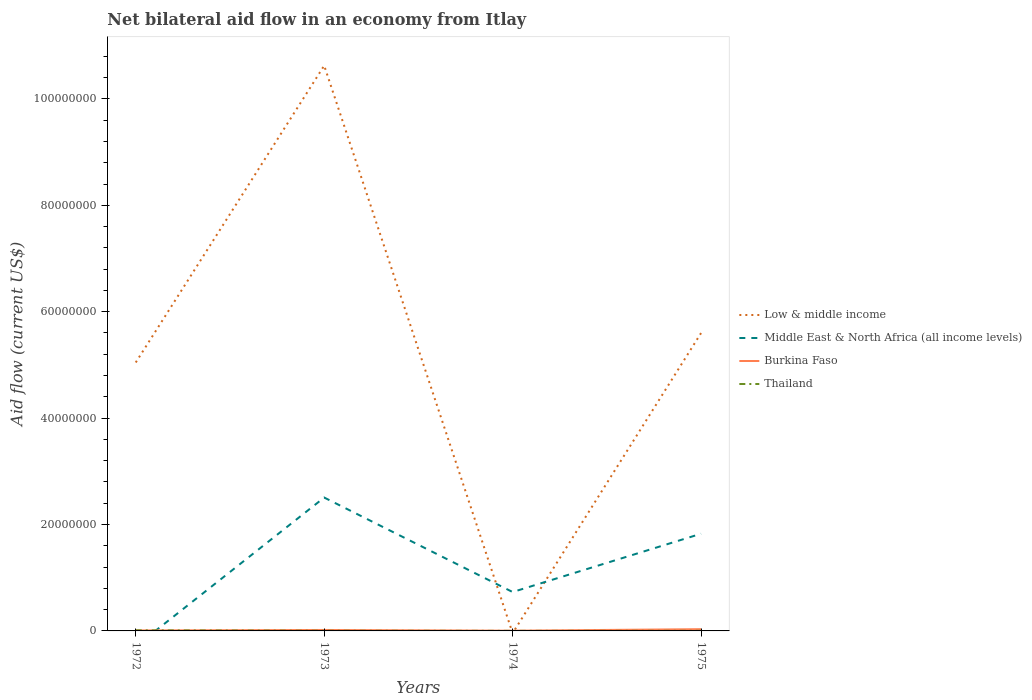How many different coloured lines are there?
Offer a very short reply. 4. Does the line corresponding to Middle East & North Africa (all income levels) intersect with the line corresponding to Burkina Faso?
Keep it short and to the point. Yes. What is the total net bilateral aid flow in Low & middle income in the graph?
Your answer should be compact. -5.53e+06. What is the difference between the highest and the second highest net bilateral aid flow in Middle East & North Africa (all income levels)?
Offer a very short reply. 2.51e+07. What is the difference between the highest and the lowest net bilateral aid flow in Burkina Faso?
Keep it short and to the point. 2. Is the net bilateral aid flow in Burkina Faso strictly greater than the net bilateral aid flow in Middle East & North Africa (all income levels) over the years?
Keep it short and to the point. No. How many lines are there?
Offer a very short reply. 4. Does the graph contain any zero values?
Offer a terse response. Yes. Does the graph contain grids?
Give a very brief answer. No. Where does the legend appear in the graph?
Give a very brief answer. Center right. How are the legend labels stacked?
Provide a succinct answer. Vertical. What is the title of the graph?
Make the answer very short. Net bilateral aid flow in an economy from Itlay. What is the label or title of the X-axis?
Provide a short and direct response. Years. What is the label or title of the Y-axis?
Ensure brevity in your answer.  Aid flow (current US$). What is the Aid flow (current US$) in Low & middle income in 1972?
Ensure brevity in your answer.  5.05e+07. What is the Aid flow (current US$) in Middle East & North Africa (all income levels) in 1972?
Give a very brief answer. 0. What is the Aid flow (current US$) in Burkina Faso in 1972?
Keep it short and to the point. 9.00e+04. What is the Aid flow (current US$) of Thailand in 1972?
Your answer should be very brief. 1.10e+05. What is the Aid flow (current US$) of Low & middle income in 1973?
Offer a terse response. 1.06e+08. What is the Aid flow (current US$) in Middle East & North Africa (all income levels) in 1973?
Provide a succinct answer. 2.51e+07. What is the Aid flow (current US$) of Low & middle income in 1974?
Provide a succinct answer. 0. What is the Aid flow (current US$) in Middle East & North Africa (all income levels) in 1974?
Give a very brief answer. 7.31e+06. What is the Aid flow (current US$) of Burkina Faso in 1974?
Your response must be concise. 4.00e+04. What is the Aid flow (current US$) of Thailand in 1974?
Provide a succinct answer. 10000. What is the Aid flow (current US$) in Low & middle income in 1975?
Offer a terse response. 5.60e+07. What is the Aid flow (current US$) of Middle East & North Africa (all income levels) in 1975?
Offer a terse response. 1.83e+07. What is the Aid flow (current US$) in Thailand in 1975?
Make the answer very short. 2.00e+04. Across all years, what is the maximum Aid flow (current US$) of Low & middle income?
Ensure brevity in your answer.  1.06e+08. Across all years, what is the maximum Aid flow (current US$) of Middle East & North Africa (all income levels)?
Ensure brevity in your answer.  2.51e+07. Across all years, what is the maximum Aid flow (current US$) in Burkina Faso?
Offer a very short reply. 3.30e+05. Across all years, what is the maximum Aid flow (current US$) in Thailand?
Provide a short and direct response. 1.10e+05. Across all years, what is the minimum Aid flow (current US$) in Low & middle income?
Offer a very short reply. 0. Across all years, what is the minimum Aid flow (current US$) in Thailand?
Provide a short and direct response. 10000. What is the total Aid flow (current US$) in Low & middle income in the graph?
Your answer should be very brief. 2.13e+08. What is the total Aid flow (current US$) in Middle East & North Africa (all income levels) in the graph?
Offer a very short reply. 5.06e+07. What is the total Aid flow (current US$) in Burkina Faso in the graph?
Keep it short and to the point. 6.40e+05. What is the total Aid flow (current US$) in Thailand in the graph?
Your answer should be very brief. 1.70e+05. What is the difference between the Aid flow (current US$) in Low & middle income in 1972 and that in 1973?
Provide a succinct answer. -5.58e+07. What is the difference between the Aid flow (current US$) in Burkina Faso in 1972 and that in 1974?
Offer a terse response. 5.00e+04. What is the difference between the Aid flow (current US$) of Thailand in 1972 and that in 1974?
Keep it short and to the point. 1.00e+05. What is the difference between the Aid flow (current US$) of Low & middle income in 1972 and that in 1975?
Your response must be concise. -5.53e+06. What is the difference between the Aid flow (current US$) of Burkina Faso in 1972 and that in 1975?
Keep it short and to the point. -2.40e+05. What is the difference between the Aid flow (current US$) of Middle East & North Africa (all income levels) in 1973 and that in 1974?
Provide a succinct answer. 1.78e+07. What is the difference between the Aid flow (current US$) of Low & middle income in 1973 and that in 1975?
Provide a succinct answer. 5.03e+07. What is the difference between the Aid flow (current US$) of Middle East & North Africa (all income levels) in 1973 and that in 1975?
Ensure brevity in your answer.  6.80e+06. What is the difference between the Aid flow (current US$) of Burkina Faso in 1973 and that in 1975?
Your answer should be very brief. -1.50e+05. What is the difference between the Aid flow (current US$) of Middle East & North Africa (all income levels) in 1974 and that in 1975?
Your response must be concise. -1.10e+07. What is the difference between the Aid flow (current US$) of Thailand in 1974 and that in 1975?
Ensure brevity in your answer.  -10000. What is the difference between the Aid flow (current US$) in Low & middle income in 1972 and the Aid flow (current US$) in Middle East & North Africa (all income levels) in 1973?
Provide a succinct answer. 2.54e+07. What is the difference between the Aid flow (current US$) in Low & middle income in 1972 and the Aid flow (current US$) in Burkina Faso in 1973?
Give a very brief answer. 5.03e+07. What is the difference between the Aid flow (current US$) of Low & middle income in 1972 and the Aid flow (current US$) of Thailand in 1973?
Offer a terse response. 5.04e+07. What is the difference between the Aid flow (current US$) in Burkina Faso in 1972 and the Aid flow (current US$) in Thailand in 1973?
Provide a succinct answer. 6.00e+04. What is the difference between the Aid flow (current US$) of Low & middle income in 1972 and the Aid flow (current US$) of Middle East & North Africa (all income levels) in 1974?
Provide a succinct answer. 4.32e+07. What is the difference between the Aid flow (current US$) in Low & middle income in 1972 and the Aid flow (current US$) in Burkina Faso in 1974?
Offer a very short reply. 5.04e+07. What is the difference between the Aid flow (current US$) of Low & middle income in 1972 and the Aid flow (current US$) of Thailand in 1974?
Make the answer very short. 5.04e+07. What is the difference between the Aid flow (current US$) in Burkina Faso in 1972 and the Aid flow (current US$) in Thailand in 1974?
Ensure brevity in your answer.  8.00e+04. What is the difference between the Aid flow (current US$) of Low & middle income in 1972 and the Aid flow (current US$) of Middle East & North Africa (all income levels) in 1975?
Your response must be concise. 3.22e+07. What is the difference between the Aid flow (current US$) of Low & middle income in 1972 and the Aid flow (current US$) of Burkina Faso in 1975?
Offer a very short reply. 5.01e+07. What is the difference between the Aid flow (current US$) in Low & middle income in 1972 and the Aid flow (current US$) in Thailand in 1975?
Your answer should be compact. 5.04e+07. What is the difference between the Aid flow (current US$) of Burkina Faso in 1972 and the Aid flow (current US$) of Thailand in 1975?
Make the answer very short. 7.00e+04. What is the difference between the Aid flow (current US$) in Low & middle income in 1973 and the Aid flow (current US$) in Middle East & North Africa (all income levels) in 1974?
Your answer should be very brief. 9.90e+07. What is the difference between the Aid flow (current US$) of Low & middle income in 1973 and the Aid flow (current US$) of Burkina Faso in 1974?
Keep it short and to the point. 1.06e+08. What is the difference between the Aid flow (current US$) of Low & middle income in 1973 and the Aid flow (current US$) of Thailand in 1974?
Your response must be concise. 1.06e+08. What is the difference between the Aid flow (current US$) in Middle East & North Africa (all income levels) in 1973 and the Aid flow (current US$) in Burkina Faso in 1974?
Offer a terse response. 2.50e+07. What is the difference between the Aid flow (current US$) in Middle East & North Africa (all income levels) in 1973 and the Aid flow (current US$) in Thailand in 1974?
Ensure brevity in your answer.  2.51e+07. What is the difference between the Aid flow (current US$) in Low & middle income in 1973 and the Aid flow (current US$) in Middle East & North Africa (all income levels) in 1975?
Keep it short and to the point. 8.80e+07. What is the difference between the Aid flow (current US$) in Low & middle income in 1973 and the Aid flow (current US$) in Burkina Faso in 1975?
Your answer should be compact. 1.06e+08. What is the difference between the Aid flow (current US$) in Low & middle income in 1973 and the Aid flow (current US$) in Thailand in 1975?
Give a very brief answer. 1.06e+08. What is the difference between the Aid flow (current US$) in Middle East & North Africa (all income levels) in 1973 and the Aid flow (current US$) in Burkina Faso in 1975?
Ensure brevity in your answer.  2.47e+07. What is the difference between the Aid flow (current US$) of Middle East & North Africa (all income levels) in 1973 and the Aid flow (current US$) of Thailand in 1975?
Provide a short and direct response. 2.50e+07. What is the difference between the Aid flow (current US$) in Middle East & North Africa (all income levels) in 1974 and the Aid flow (current US$) in Burkina Faso in 1975?
Provide a succinct answer. 6.98e+06. What is the difference between the Aid flow (current US$) of Middle East & North Africa (all income levels) in 1974 and the Aid flow (current US$) of Thailand in 1975?
Give a very brief answer. 7.29e+06. What is the average Aid flow (current US$) in Low & middle income per year?
Provide a short and direct response. 5.32e+07. What is the average Aid flow (current US$) of Middle East & North Africa (all income levels) per year?
Keep it short and to the point. 1.27e+07. What is the average Aid flow (current US$) of Burkina Faso per year?
Your answer should be compact. 1.60e+05. What is the average Aid flow (current US$) of Thailand per year?
Give a very brief answer. 4.25e+04. In the year 1972, what is the difference between the Aid flow (current US$) in Low & middle income and Aid flow (current US$) in Burkina Faso?
Provide a succinct answer. 5.04e+07. In the year 1972, what is the difference between the Aid flow (current US$) of Low & middle income and Aid flow (current US$) of Thailand?
Ensure brevity in your answer.  5.04e+07. In the year 1972, what is the difference between the Aid flow (current US$) in Burkina Faso and Aid flow (current US$) in Thailand?
Provide a succinct answer. -2.00e+04. In the year 1973, what is the difference between the Aid flow (current US$) of Low & middle income and Aid flow (current US$) of Middle East & North Africa (all income levels)?
Provide a succinct answer. 8.12e+07. In the year 1973, what is the difference between the Aid flow (current US$) in Low & middle income and Aid flow (current US$) in Burkina Faso?
Your answer should be very brief. 1.06e+08. In the year 1973, what is the difference between the Aid flow (current US$) in Low & middle income and Aid flow (current US$) in Thailand?
Provide a succinct answer. 1.06e+08. In the year 1973, what is the difference between the Aid flow (current US$) in Middle East & North Africa (all income levels) and Aid flow (current US$) in Burkina Faso?
Ensure brevity in your answer.  2.49e+07. In the year 1973, what is the difference between the Aid flow (current US$) of Middle East & North Africa (all income levels) and Aid flow (current US$) of Thailand?
Provide a short and direct response. 2.50e+07. In the year 1973, what is the difference between the Aid flow (current US$) of Burkina Faso and Aid flow (current US$) of Thailand?
Ensure brevity in your answer.  1.50e+05. In the year 1974, what is the difference between the Aid flow (current US$) of Middle East & North Africa (all income levels) and Aid flow (current US$) of Burkina Faso?
Your response must be concise. 7.27e+06. In the year 1974, what is the difference between the Aid flow (current US$) in Middle East & North Africa (all income levels) and Aid flow (current US$) in Thailand?
Offer a very short reply. 7.30e+06. In the year 1974, what is the difference between the Aid flow (current US$) of Burkina Faso and Aid flow (current US$) of Thailand?
Offer a very short reply. 3.00e+04. In the year 1975, what is the difference between the Aid flow (current US$) of Low & middle income and Aid flow (current US$) of Middle East & North Africa (all income levels)?
Your answer should be compact. 3.77e+07. In the year 1975, what is the difference between the Aid flow (current US$) in Low & middle income and Aid flow (current US$) in Burkina Faso?
Make the answer very short. 5.57e+07. In the year 1975, what is the difference between the Aid flow (current US$) in Low & middle income and Aid flow (current US$) in Thailand?
Offer a terse response. 5.60e+07. In the year 1975, what is the difference between the Aid flow (current US$) in Middle East & North Africa (all income levels) and Aid flow (current US$) in Burkina Faso?
Offer a terse response. 1.79e+07. In the year 1975, what is the difference between the Aid flow (current US$) of Middle East & North Africa (all income levels) and Aid flow (current US$) of Thailand?
Keep it short and to the point. 1.82e+07. What is the ratio of the Aid flow (current US$) in Low & middle income in 1972 to that in 1973?
Your response must be concise. 0.47. What is the ratio of the Aid flow (current US$) in Burkina Faso in 1972 to that in 1973?
Keep it short and to the point. 0.5. What is the ratio of the Aid flow (current US$) in Thailand in 1972 to that in 1973?
Your answer should be compact. 3.67. What is the ratio of the Aid flow (current US$) in Burkina Faso in 1972 to that in 1974?
Give a very brief answer. 2.25. What is the ratio of the Aid flow (current US$) of Thailand in 1972 to that in 1974?
Offer a very short reply. 11. What is the ratio of the Aid flow (current US$) in Low & middle income in 1972 to that in 1975?
Provide a short and direct response. 0.9. What is the ratio of the Aid flow (current US$) of Burkina Faso in 1972 to that in 1975?
Your answer should be very brief. 0.27. What is the ratio of the Aid flow (current US$) in Thailand in 1972 to that in 1975?
Provide a short and direct response. 5.5. What is the ratio of the Aid flow (current US$) in Middle East & North Africa (all income levels) in 1973 to that in 1974?
Offer a very short reply. 3.43. What is the ratio of the Aid flow (current US$) of Burkina Faso in 1973 to that in 1974?
Provide a short and direct response. 4.5. What is the ratio of the Aid flow (current US$) of Thailand in 1973 to that in 1974?
Your response must be concise. 3. What is the ratio of the Aid flow (current US$) in Low & middle income in 1973 to that in 1975?
Provide a short and direct response. 1.9. What is the ratio of the Aid flow (current US$) in Middle East & North Africa (all income levels) in 1973 to that in 1975?
Provide a short and direct response. 1.37. What is the ratio of the Aid flow (current US$) in Burkina Faso in 1973 to that in 1975?
Ensure brevity in your answer.  0.55. What is the ratio of the Aid flow (current US$) in Middle East & North Africa (all income levels) in 1974 to that in 1975?
Give a very brief answer. 0.4. What is the ratio of the Aid flow (current US$) of Burkina Faso in 1974 to that in 1975?
Make the answer very short. 0.12. What is the ratio of the Aid flow (current US$) of Thailand in 1974 to that in 1975?
Offer a terse response. 0.5. What is the difference between the highest and the second highest Aid flow (current US$) in Low & middle income?
Give a very brief answer. 5.03e+07. What is the difference between the highest and the second highest Aid flow (current US$) of Middle East & North Africa (all income levels)?
Offer a terse response. 6.80e+06. What is the difference between the highest and the second highest Aid flow (current US$) in Thailand?
Provide a short and direct response. 8.00e+04. What is the difference between the highest and the lowest Aid flow (current US$) in Low & middle income?
Your answer should be compact. 1.06e+08. What is the difference between the highest and the lowest Aid flow (current US$) in Middle East & North Africa (all income levels)?
Provide a short and direct response. 2.51e+07. What is the difference between the highest and the lowest Aid flow (current US$) in Burkina Faso?
Provide a succinct answer. 2.90e+05. What is the difference between the highest and the lowest Aid flow (current US$) of Thailand?
Give a very brief answer. 1.00e+05. 